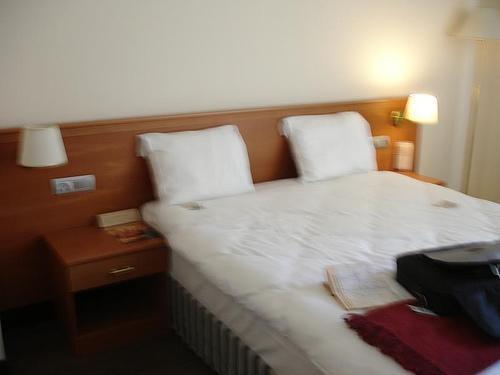How many people should fit in this bed size?
Give a very brief answer. 2. How many lamps are turned on?
Give a very brief answer. 1. How many sets of towels on the bed?
Give a very brief answer. 1. How many pillows are there?
Give a very brief answer. 2. 